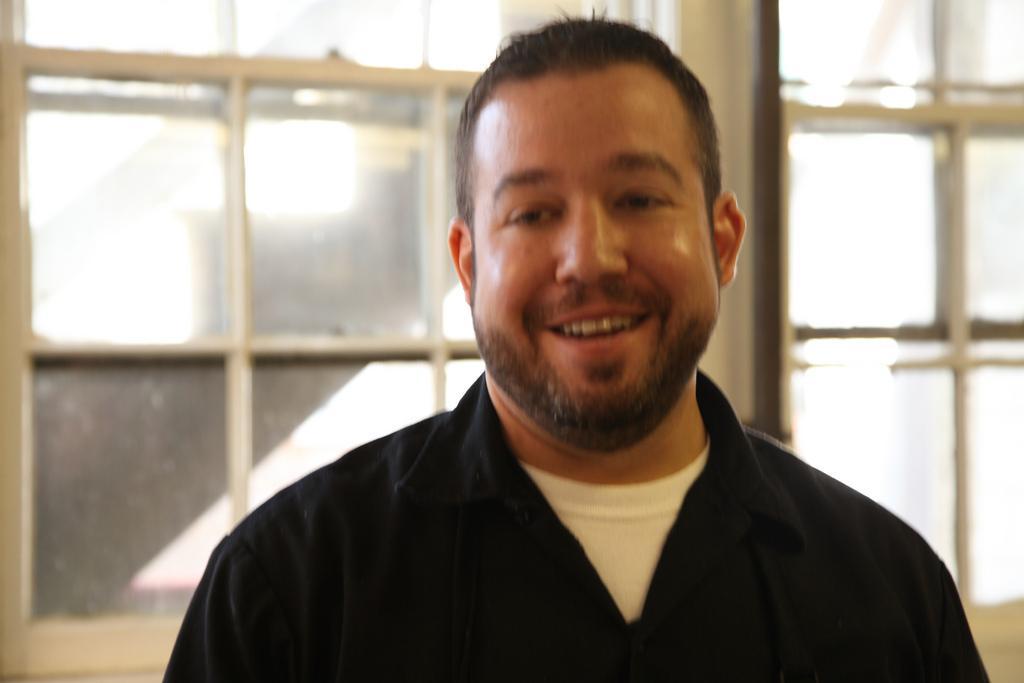How would you summarize this image in a sentence or two? In this image we can see a person. On the backside we can see some windows. 